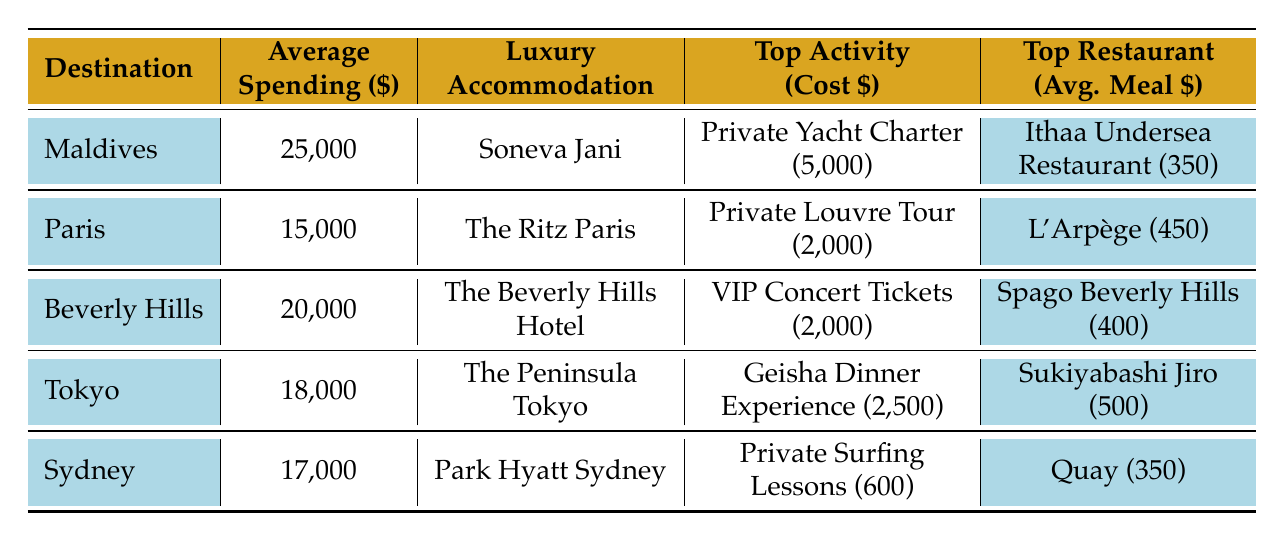What is the average spending per trip in Maldives? From the table, the average spending per trip to the Maldives is listed directly as \$25,000.
Answer: 25000 What is the luxury accommodation in Paris? The luxury accommodation for Paris is specified directly in the table as "The Ritz Paris."
Answer: The Ritz Paris Which destination has the highest average spending per trip? Comparing the average spending values from the table, Maldives has \$25,000, Paris \$15,000, Beverly Hills \$20,000, Tokyo \$18,000, and Sydney \$17,000. Maldives has the highest value at \$25,000.
Answer: Maldives What is the average meal cost at L'Arpège? The table shows the average meal cost at L'Arpège as \$450.
Answer: 450 Which destination has a top restaurant with an average meal cost of less than \$400? Looking at the table, the average meal costs at Quay (\$350), Mastro's Steakhouse (\$350), and Fresh in the Garden (\$250) are all less than \$400. Sydney and Maldives are among the destinations that have such restaurants.
Answer: Sydney and Maldives How much would it cost to do both the Private Yacht Charter in Maldives and the Private Louvre Tour in Paris? The average cost for the Private Yacht Charter is \$5,000, and for the Private Louvre Tour, it is \$2,000. Adding these two amounts together gives \$5,000 + \$2,000 = \$7,000.
Answer: 7000 Which destination offers the most expensive top activity? From the table, the activities and their costs are: Private Yacht Charter in Maldives (\$5,000), Private Louvre Tour in Paris (\$2,000), VIP Concert Tickets in Beverly Hills (\$2,000), Geisha Dinner Experience in Tokyo (\$2,500), and Private Surfing Lessons in Sydney (\$600). The Private Yacht Charter in Maldives is the most expensive at \$5,000.
Answer: Maldives How much more does an average trip to Beverly Hills cost compared to Tokyo? The average trip to Beverly Hills costs \$20,000 while Tokyo costs \$18,000. The difference is \$20,000 - \$18,000 = \$2,000.
Answer: 2000 Are there any activities in Sydney that cost more than \$300? Analyzing the activities in Sydney, the Harbor Bridge Climb costs \$250, the Private Surfing Lessons cost \$600, and the Wine Tasting Tour costs \$300. The Private Surfing Lessons at \$600 is the only one above \$300, hence, yes, there are activities that cost more than \$300 in Sydney.
Answer: Yes What is the average spending on trips across all destinations? To calculate the average spending, we first sum the average spending from each destination: \$25,000 (Maldives) + \$15,000 (Paris) + \$20,000 (Beverly Hills) + \$18,000 (Tokyo) + \$17,000 (Sydney) = \$95,000. Now we divide \$95,000 by the number of destinations, which is 5: \$95,000 / 5 = \$19,000.
Answer: 19000 